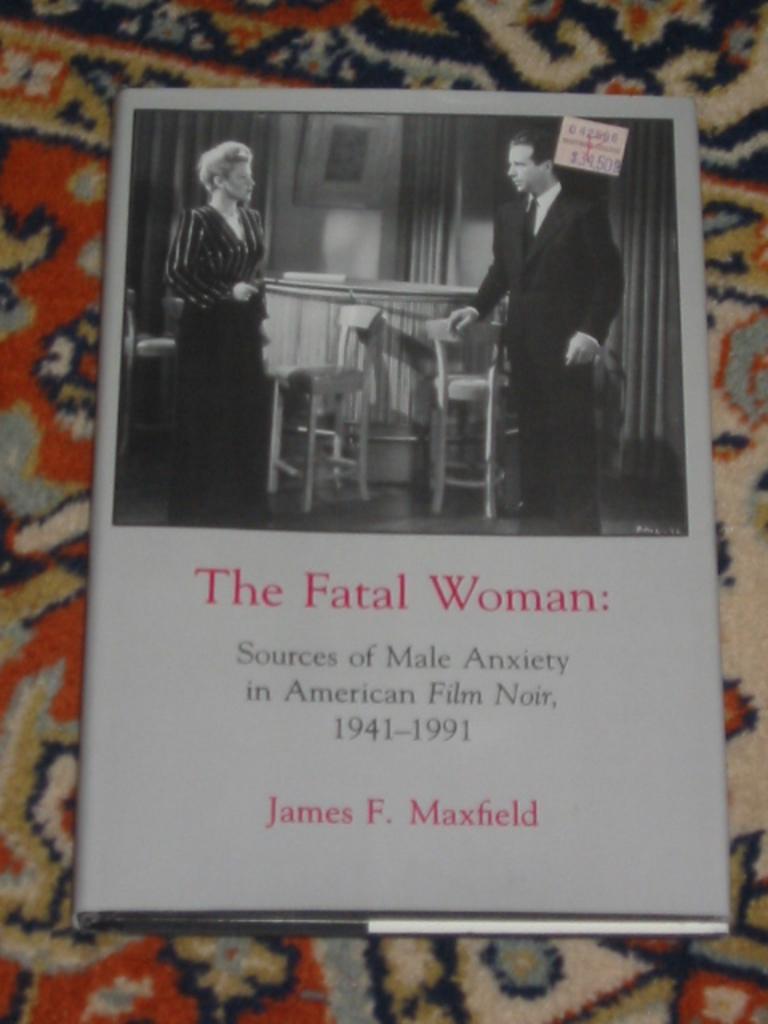In one or two sentences, can you explain what this image depicts? In this picture we can see a book placed on a cloth and on this book we can see two people, table, chairs, curtains, stamp and some text. 